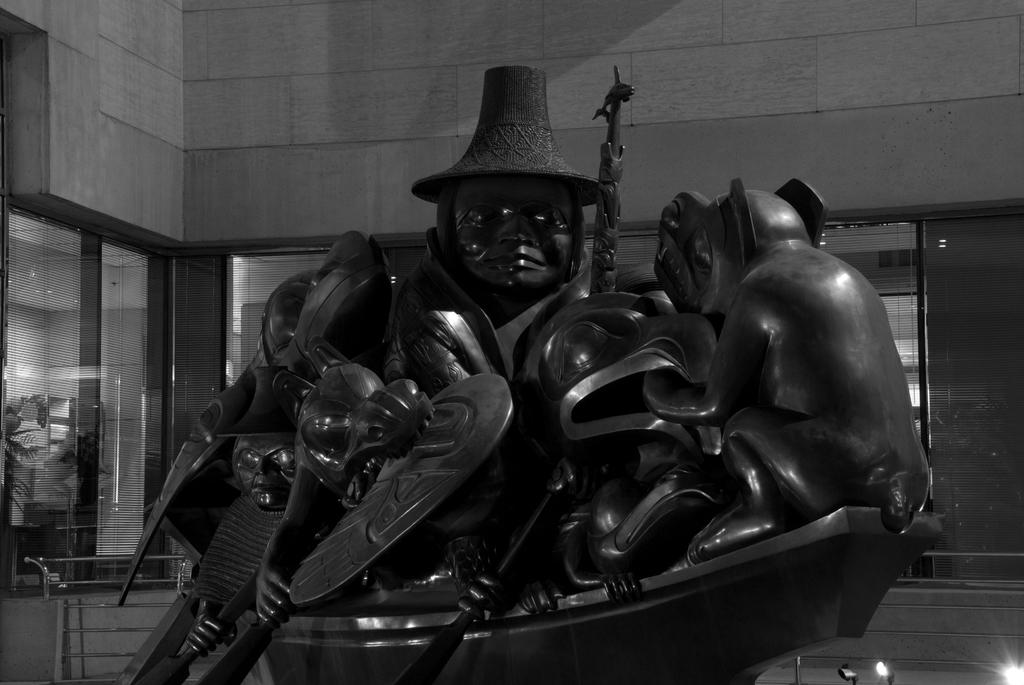What is depicted in the statue in the image? The statue is of persons sitting in a boat. Where is the statue located in relation to the building? The statue is in front of a building. What can be seen in the right bottom corner of the image? There are lights in the right bottom corner of the image. What type of desk can be seen in the library in the image? There is no desk or library present in the image; it features a statue of persons sitting in a boat in front of a building. 